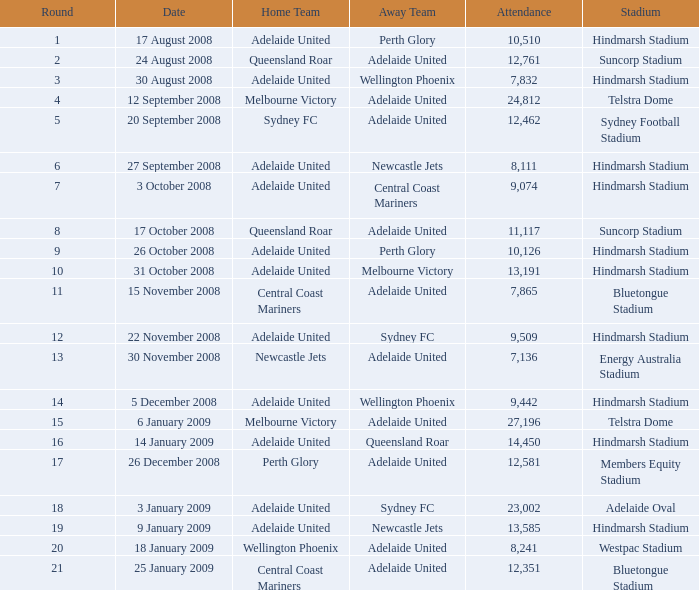What is the minimum round for the game held at members equity stadium in front of 12,581 individuals? None. 